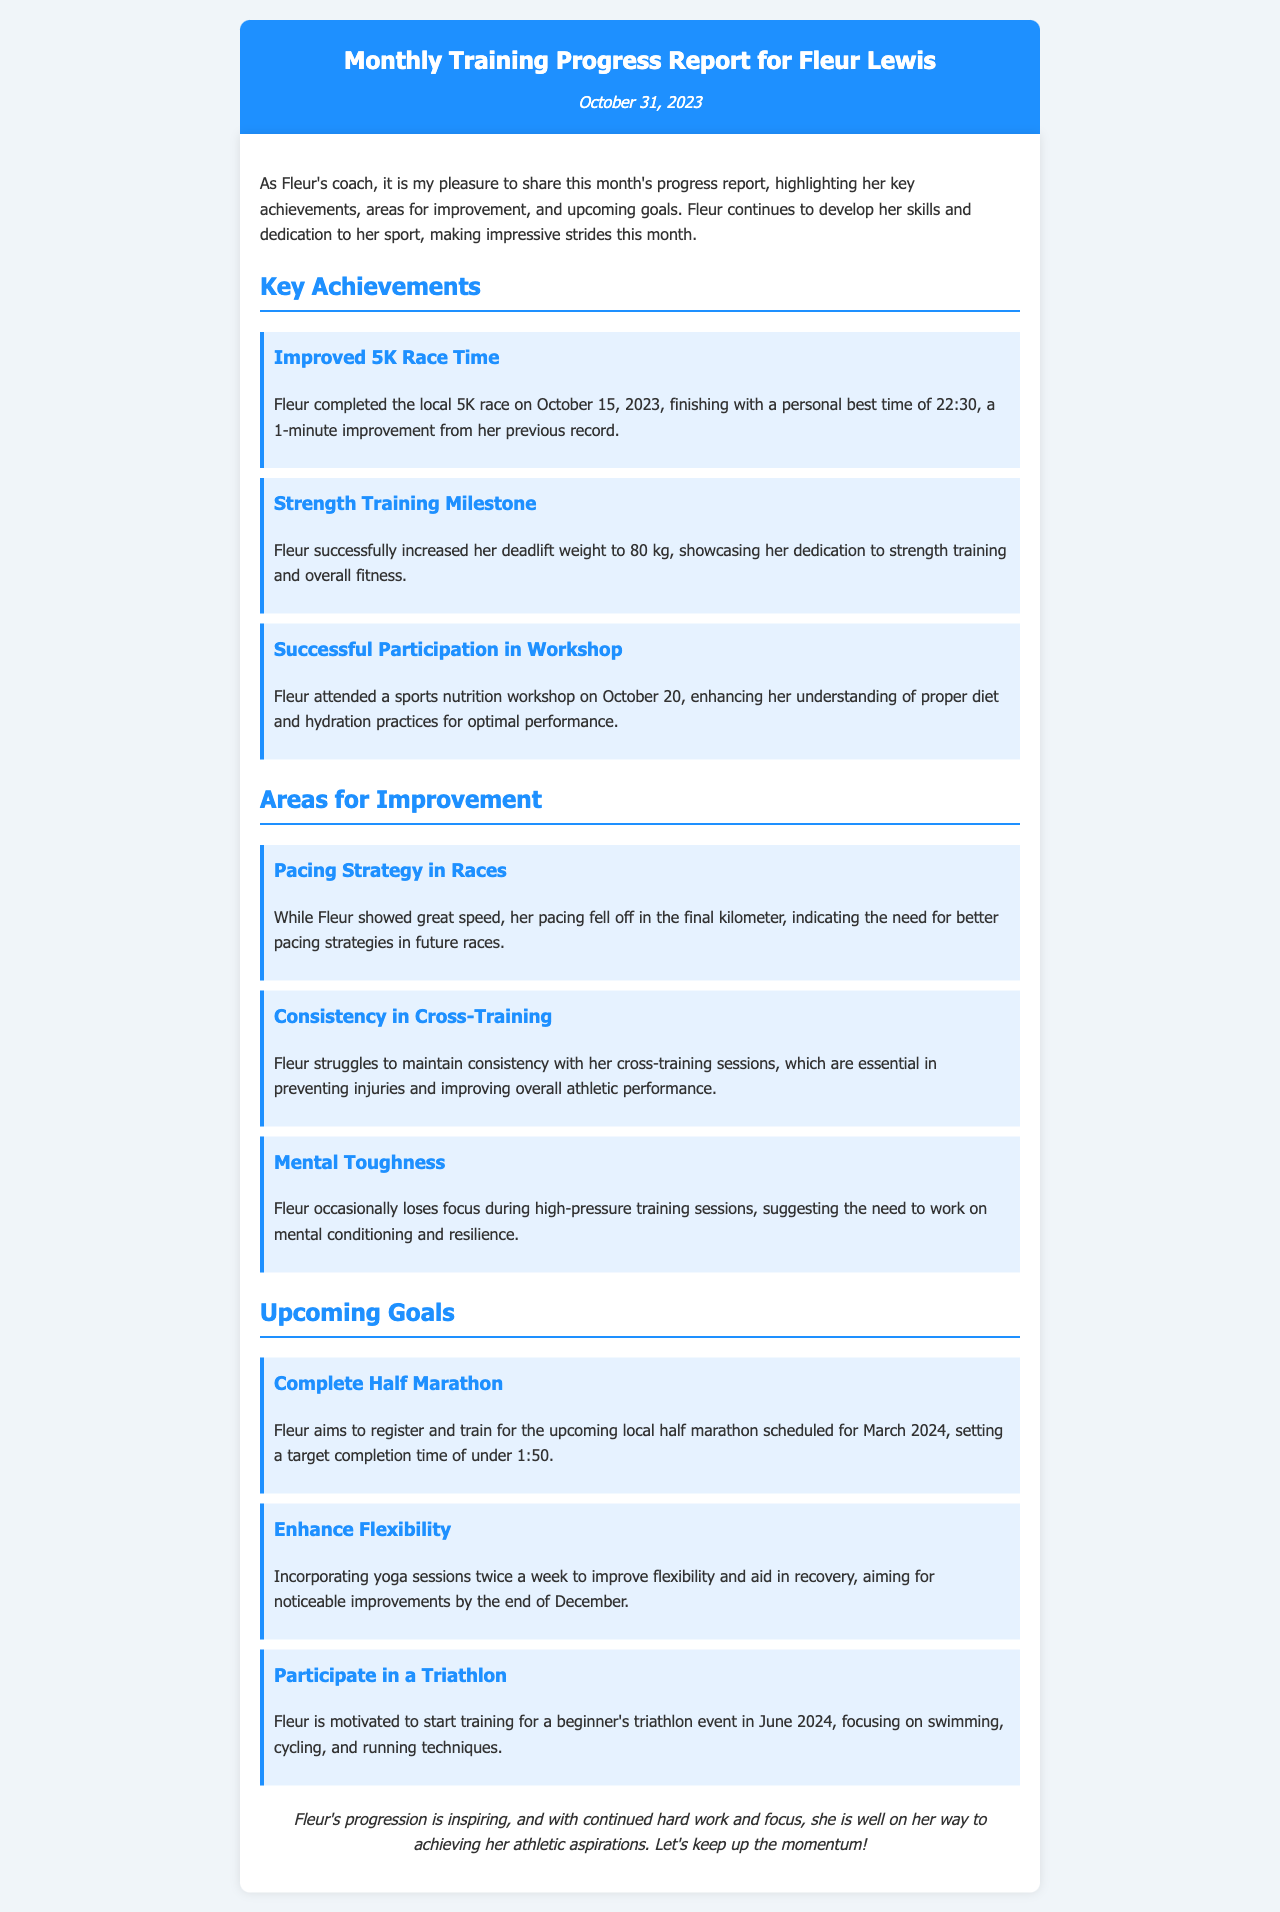What is Fleur's personal best time in the 5K race? The document states that Fleur completed the local 5K race with a personal best time of 22:30.
Answer: 22:30 When did Fleur attend the sports nutrition workshop? The document mentions that Fleur attended the sports nutrition workshop on October 20, 2023.
Answer: October 20, 2023 How much weight did Fleur increase her deadlift to? The report indicates that Fleur successfully increased her deadlift weight to 80 kg.
Answer: 80 kg What is one area Fleur needs to improve according to the report? The report identifies "Pacing Strategy in Races" as one area for improvement.
Answer: Pacing Strategy in Races What upcoming goal includes a target completion time? The upcoming goal to "Complete Half Marathon" includes a target completion time of under 1:50.
Answer: Under 1:50 How many setbacks did Fleur face in maintaining cross-training consistency? The report highlights that Fleur struggles with consistency in her cross-training sessions.
Answer: Consistency What is Fleur's aim regarding yoga sessions? The document states that Fleur aims to incorporate yoga sessions twice a week.
Answer: Twice a week What month is the local half marathon scheduled for? The upcoming local half marathon is scheduled for March 2024.
Answer: March 2024 